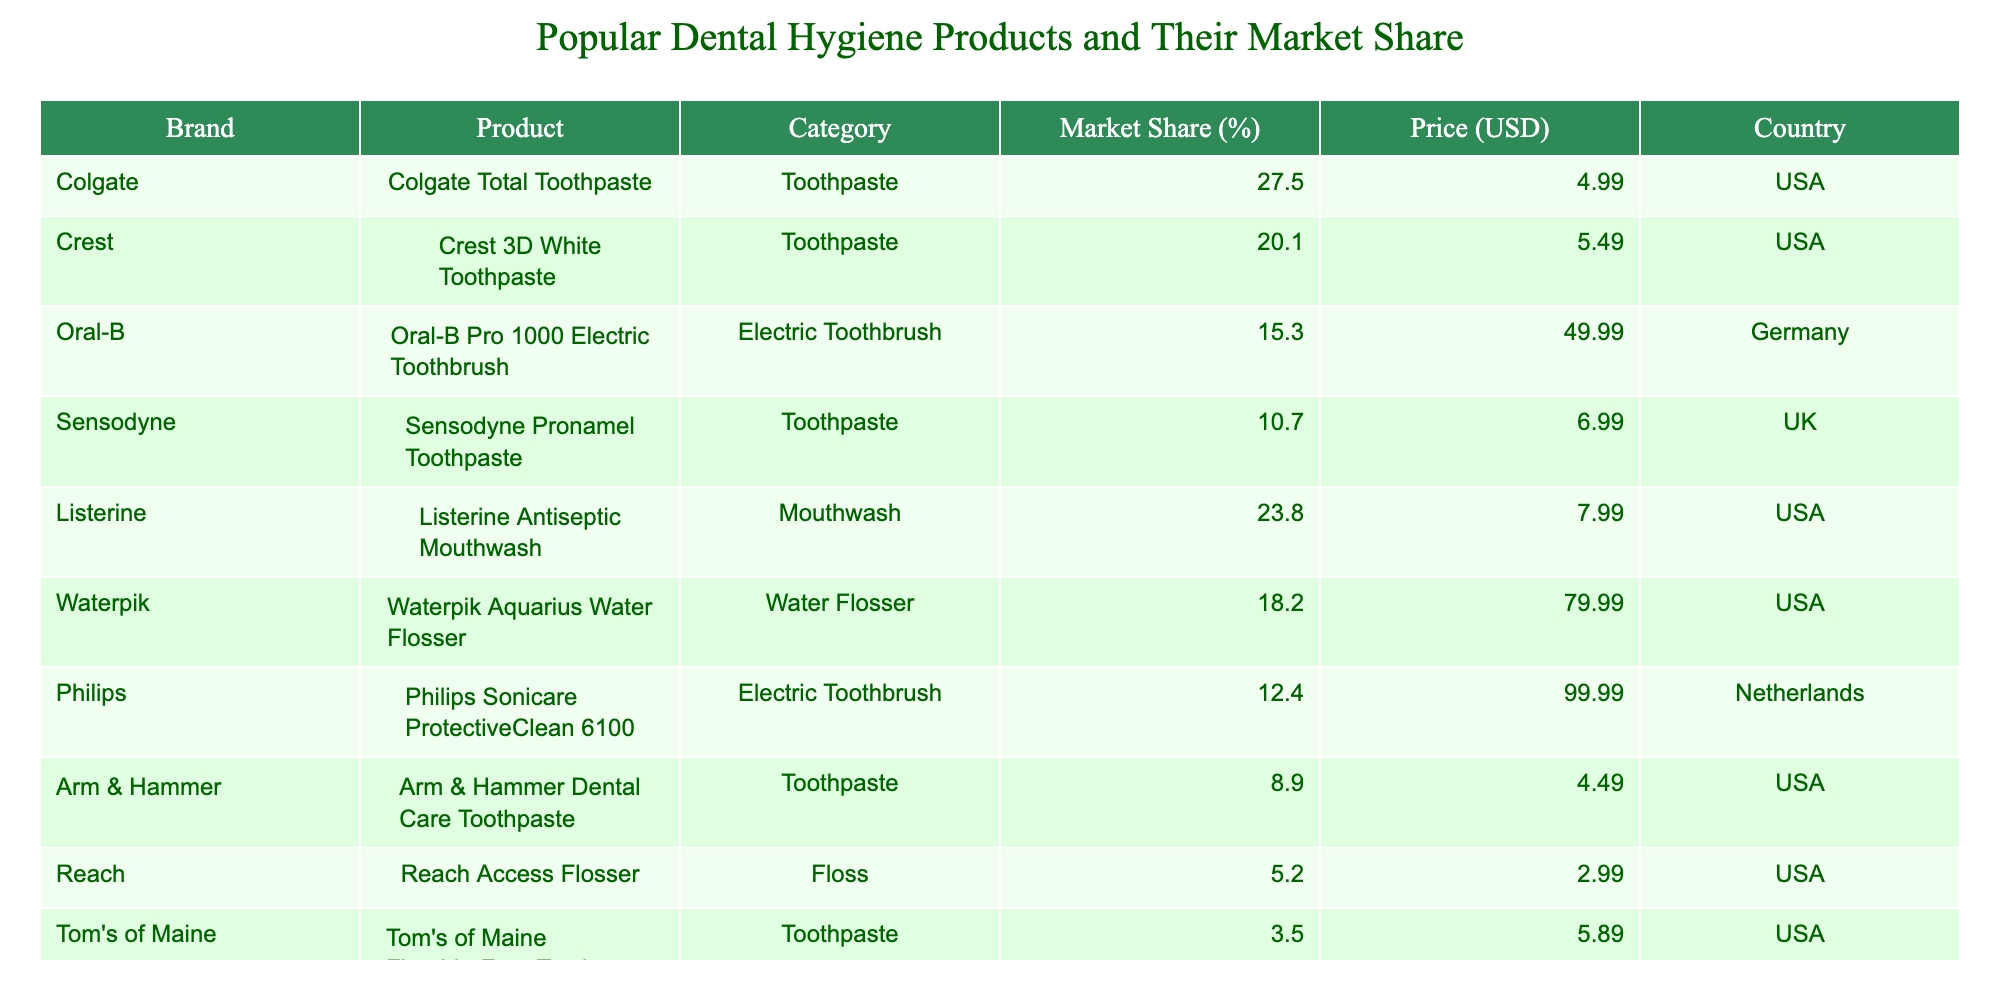What is the market share of Colgate Total Toothpaste? According to the table, the market share of Colgate Total Toothpaste is explicitly listed as 27.5%.
Answer: 27.5% Which product has the highest market share? The table shows that Colgate Total Toothpaste has the highest market share at 27.5%, which is greater than any other product listed.
Answer: Colgate Total Toothpaste What is the price of the Oral-B Pro 1000 Electric Toothbrush? The price listed for the Oral-B Pro 1000 Electric Toothbrush in the table is 49.99 USD.
Answer: 49.99 USD How many products have a market share greater than 20%? The table lists Colgate Total Toothpaste (27.5%), Listerine Antiseptic Mouthwash (23.8%), and Crest 3D White Toothpaste (20.1%). Therefore, there are three products with a market share above 20%.
Answer: 3 What is the average market share of the toothpaste products listed? The toothpaste products and their market shares are Colgate Total (27.5%), Crest 3D White (20.1%), Sensodyne Pronamel (10.7%), Arm & Hammer (8.9%), and Tom's of Maine (3.5%). Their total market share is 70.7%, and since there are 5 toothpaste products, the average is 70.7% / 5 = 14.14%.
Answer: 14.14% Is the market share of Sensodyne Pronamel greater than that of Waterpik Aquarius Water Flosser? The table shows that Sensodyne Pronamel has a market share of 10.7%, while Waterpik Aquarius has a market share of 18.2%. Since 10.7% is less than 18.2%, the statement is false.
Answer: No Which category has the least representation in terms of market share, according to the table? By examining the market shares of different categories, Toothpaste has the highest total market share, while Floss (Reach Access Flosser) has the least with only 5.2%. Thus, Floss has the least representation.
Answer: Floss What is the price difference between the most expensive product and the least expensive product? The most expensive product is Philips Sonicare ProtectiveClean 6100 at 99.99 USD, and the least expensive product is Reach Access Flosser at 2.99 USD. The price difference is calculated as 99.99 - 2.99 = 97 USD.
Answer: 97 USD Are there more electric toothbrushes or toothpaste products in the table? The table displays three toothpaste products (Colgate, Crest, Sensodyne, Arm & Hammer, Tom's of Maine) and two electric toothbrushes (Oral-B and Philips). Since there are five toothpaste products and two electric toothbrushes, the answer is that there are more toothpaste products.
Answer: Yes What is the total market share of mouthwash products? The only mouthwash listed in the table is Listerine Antiseptic Mouthwash, which has a market share of 23.8%. Since there are no other mouthwash products listed, the total market share is simply 23.8%.
Answer: 23.8% 